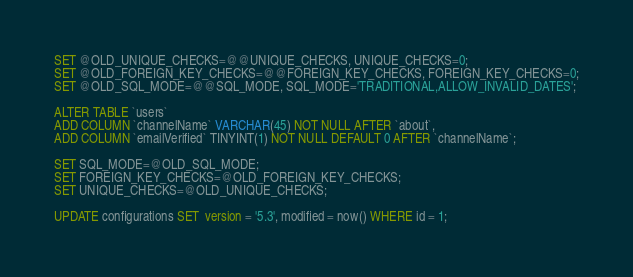<code> <loc_0><loc_0><loc_500><loc_500><_SQL_>SET @OLD_UNIQUE_CHECKS=@@UNIQUE_CHECKS, UNIQUE_CHECKS=0;
SET @OLD_FOREIGN_KEY_CHECKS=@@FOREIGN_KEY_CHECKS, FOREIGN_KEY_CHECKS=0;
SET @OLD_SQL_MODE=@@SQL_MODE, SQL_MODE='TRADITIONAL,ALLOW_INVALID_DATES';

ALTER TABLE `users` 
ADD COLUMN `channelName` VARCHAR(45) NOT NULL AFTER `about`,
ADD COLUMN `emailVerified` TINYINT(1) NOT NULL DEFAULT 0 AFTER `channelName`;

SET SQL_MODE=@OLD_SQL_MODE;
SET FOREIGN_KEY_CHECKS=@OLD_FOREIGN_KEY_CHECKS;
SET UNIQUE_CHECKS=@OLD_UNIQUE_CHECKS;

UPDATE configurations SET  version = '5.3', modified = now() WHERE id = 1;</code> 